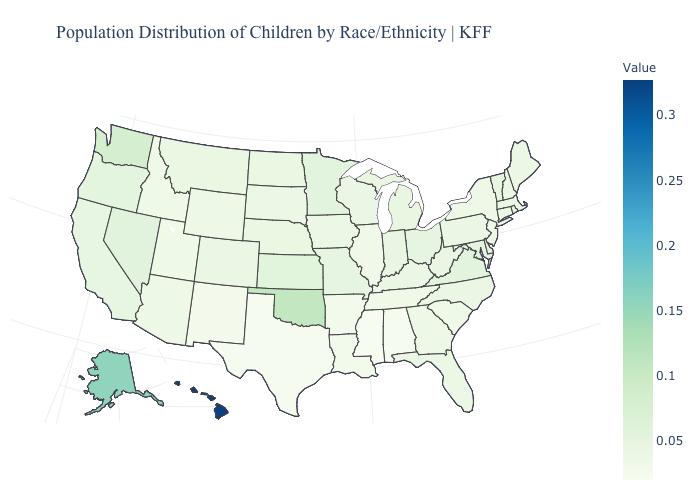Does Nevada have a lower value than Hawaii?
Be succinct. Yes. Does Indiana have the highest value in the USA?
Keep it brief. No. Does the map have missing data?
Write a very short answer. No. Does New Hampshire have a higher value than Oklahoma?
Be succinct. No. Is the legend a continuous bar?
Give a very brief answer. Yes. 